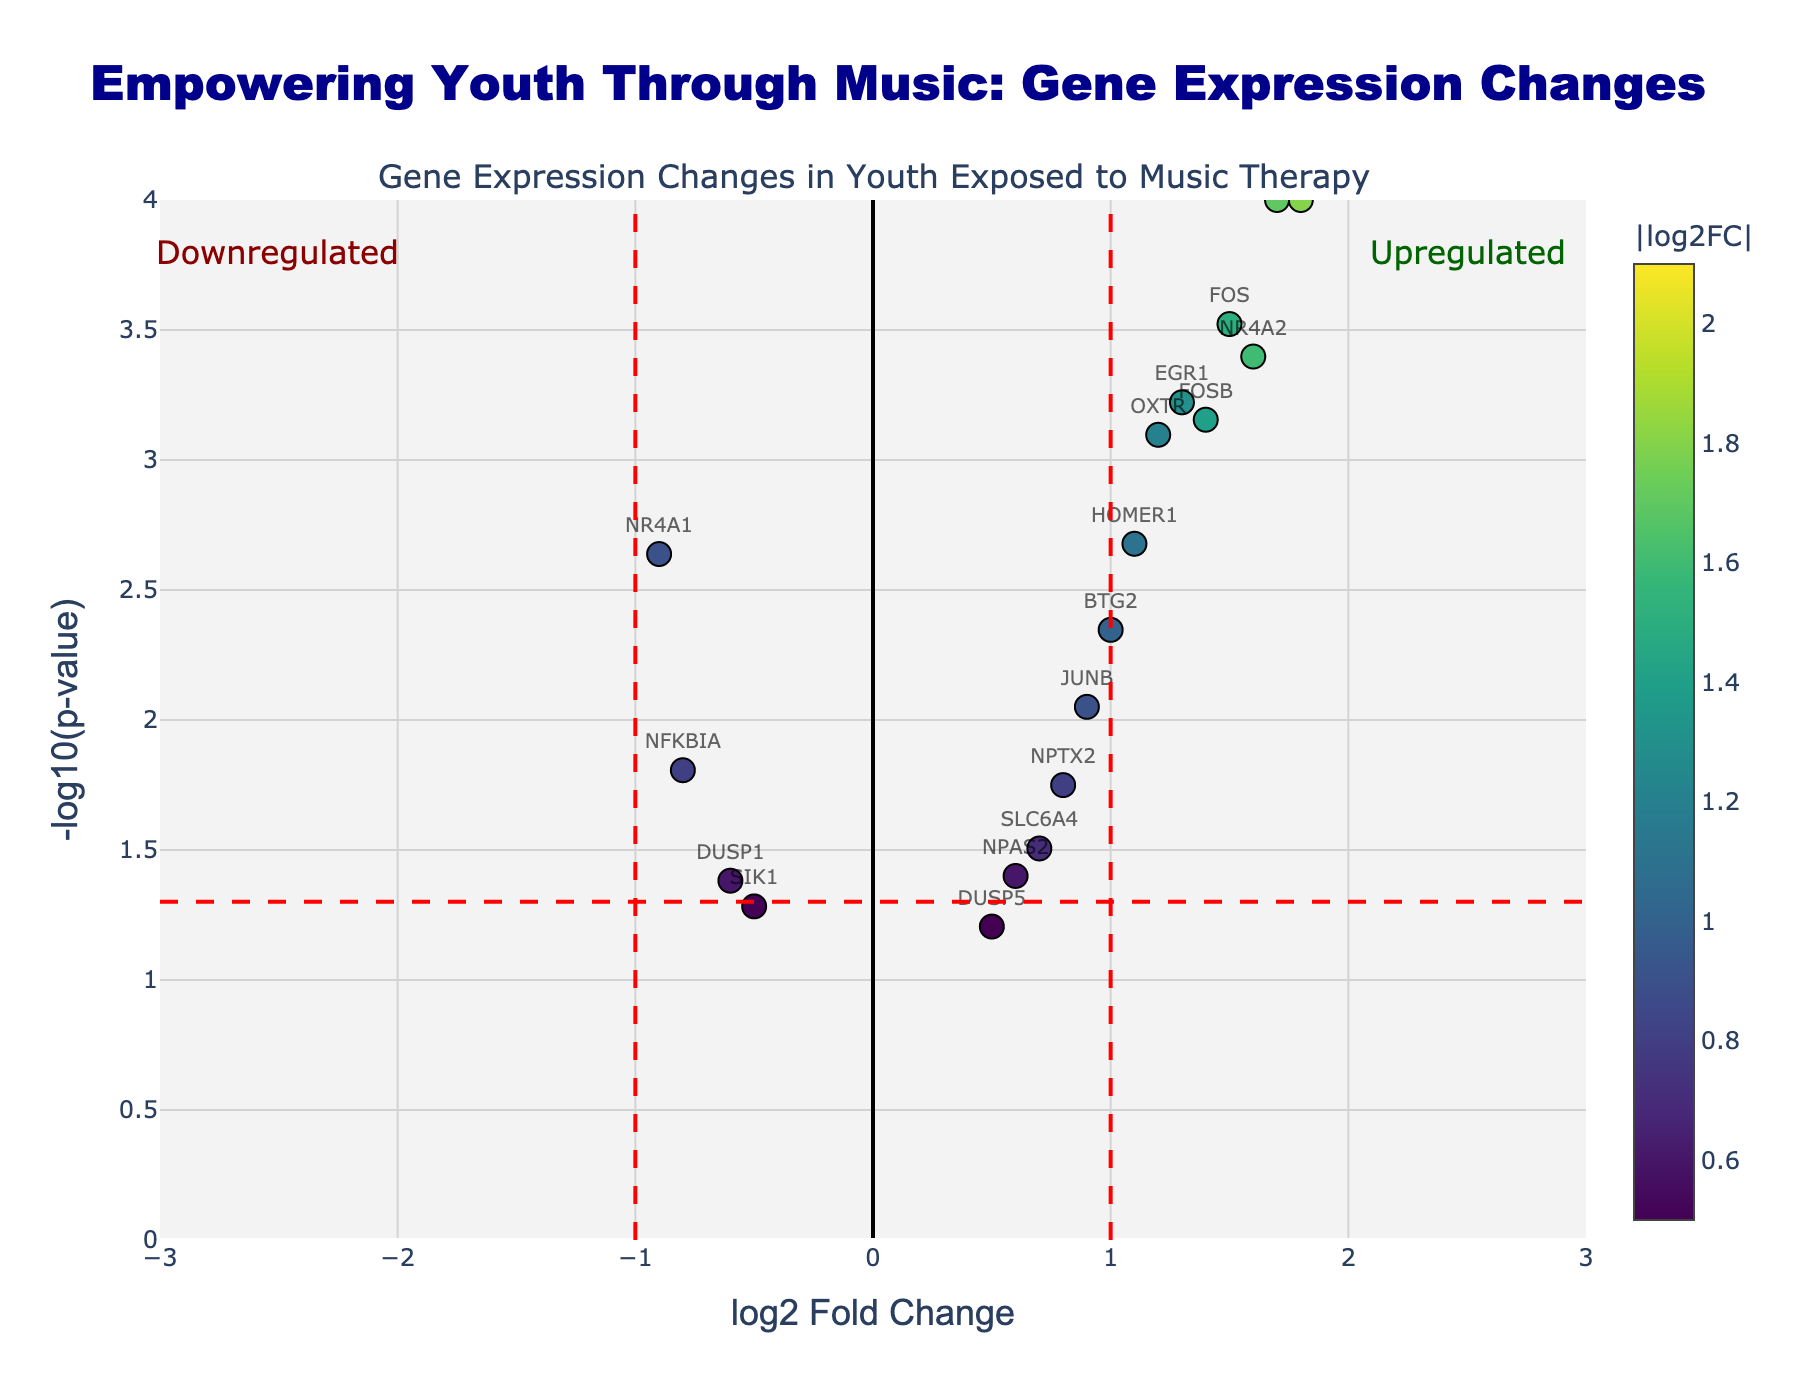What is the title of the plot? At the top of the plot, the title reads "Empowering Youth Through Music: Gene Expression Changes".
Answer: Empowering Youth Through Music: Gene Expression Changes Which gene has the highest log2 fold change? The gene with the highest log2 fold change is represented by the point farthest to the right on the x-axis. In this case, it is NPAS4 with a log2 fold change of 2.1.
Answer: NPAS4 How many genes have a significant p-value (below 0.05)? To determine how many genes have significant p-values, count the number of data points above the horizontal threshold line (since -log10(p-value) > 1.3 corresponds to p-value < 0.05). Upon counting, there are 17 such genes.
Answer: 17 What does a log2 fold change greater than 1 indicate? A log2 fold change greater than 1 suggests that the gene is significantly upregulated in the music therapy group compared to the control.
Answer: Upregulated Which gene has a significant downregulation? To identify a significantly downregulated gene, look for a point to the left of the vertical threshold line at -1 with a y-value higher than 1.3 (for significance). NR4A1 with log2FC of -0.9 and a p-value of 0.0023 fits this criterion.
Answer: NR4A1 What is the color scale used for the data points? The data points are colored based on the absolute value of their log2 fold change, with colors coming from the Viridis color scale, as indicated by the color bar.
Answer: Viridis Which gene has the lowest p-value? The gene with the lowest p-value can be identified by the highest y-value on the plot. ARC has the highest y-value, which corresponds to the lowest p-value of 0.00002.
Answer: ARC Are there more upregulated or downregulated genes based on the plot? Count the data points on the right side of the positive vertical threshold line (log2FC > 1) for upregulated genes and on the left side of the negative vertical threshold line (log2FC < -1) for downregulated genes. There are more upregulated genes.
Answer: More upregulated genes How does the plot indicate statistically significant results? The plot uses a dashed horizontal line at -log10(p-value) = 1.3 and dashed vertical lines at log2 fold change = ±1 to show significance thresholds. Data points beyond these lines are considered statistically significant.
Answer: Dashed lines indicate significance thresholds Which two genes are upregulated and have a similar log2 fold change around 1.5? The genes with similar log2 fold changes around 1.5 are FOS (1.5) and FOSB (1.4).
Answer: FOS and FOSB 